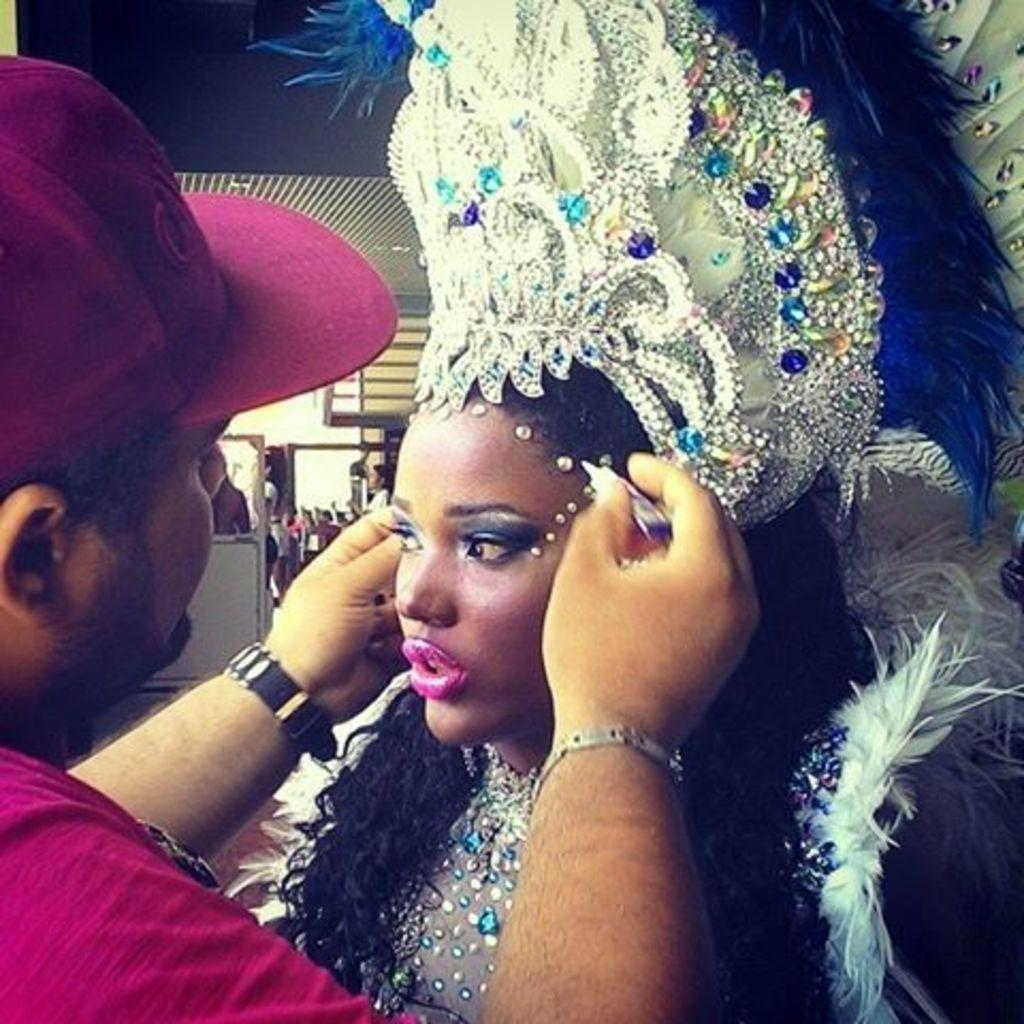How many people are present in the image? There are two people, a man and a woman, present in the image. What is the woman wearing in the image? The woman is wearing a costume in the image. What type of headwear is the man wearing in the image? The man is wearing a cap in the image. What can be seen in the background of the image? There are people, a ceiling, and other objects present in the background of the image. Can you see the ocean in the background of the image? No, the ocean is not present in the background of the image. Is there a parcel being delivered by a person in the image? There is no mention of a parcel or a person delivering it in the image. 